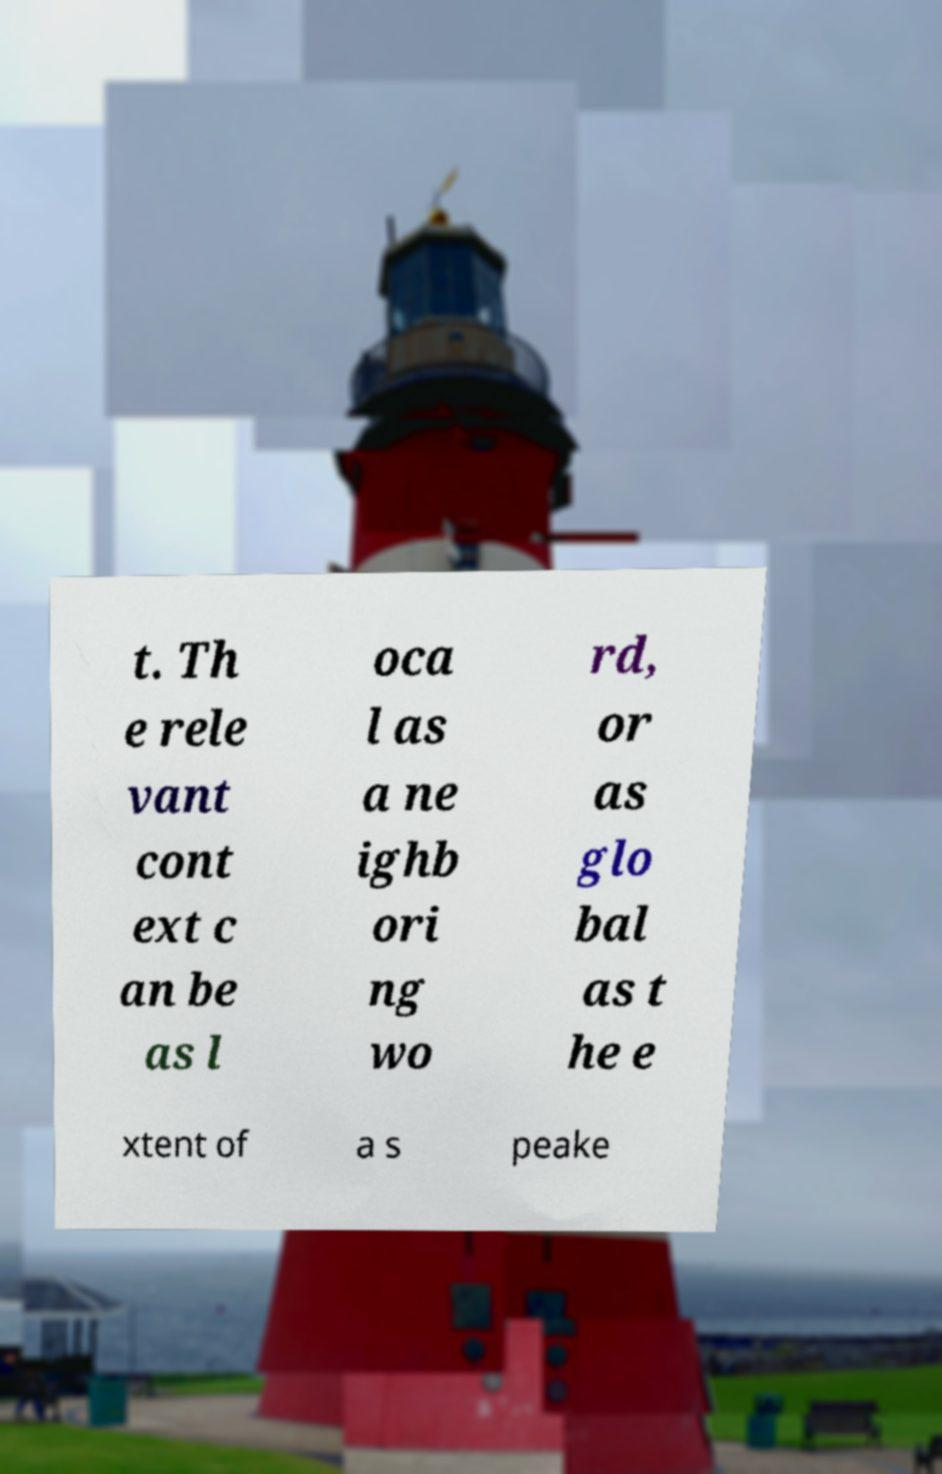There's text embedded in this image that I need extracted. Can you transcribe it verbatim? t. Th e rele vant cont ext c an be as l oca l as a ne ighb ori ng wo rd, or as glo bal as t he e xtent of a s peake 